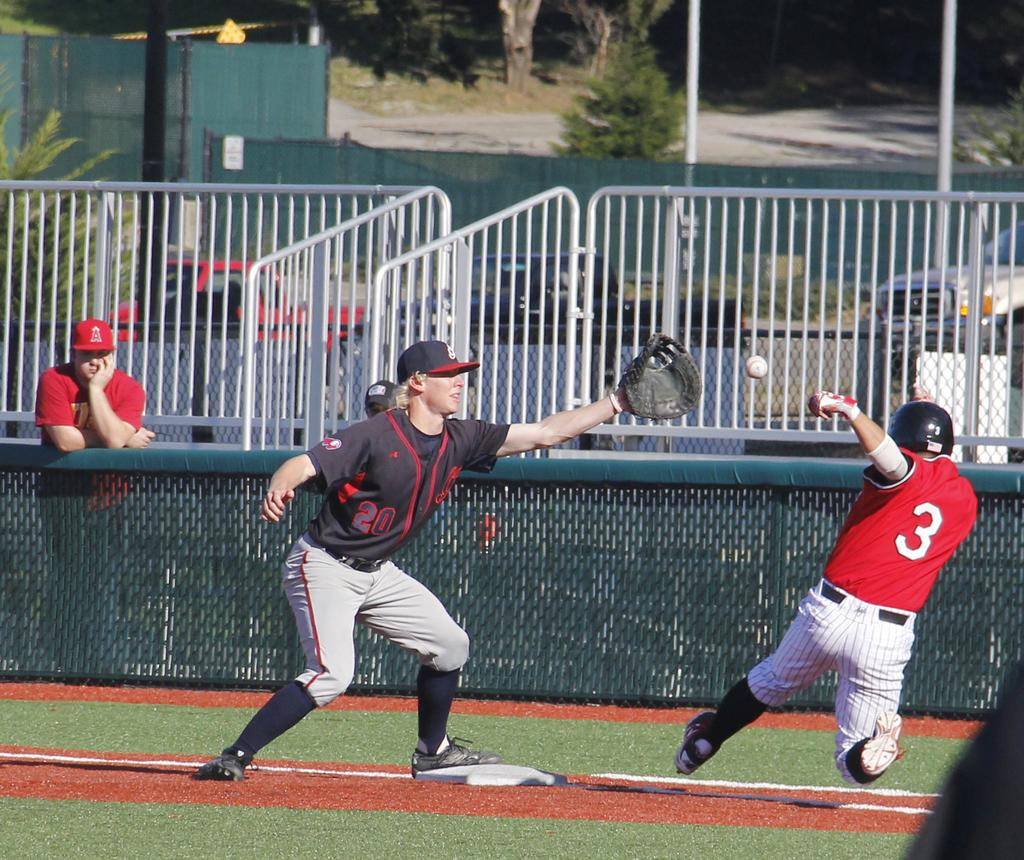<image>
Render a clear and concise summary of the photo. During a baseball game, number 3 races for the base as number 20 tries to catch the ball. 